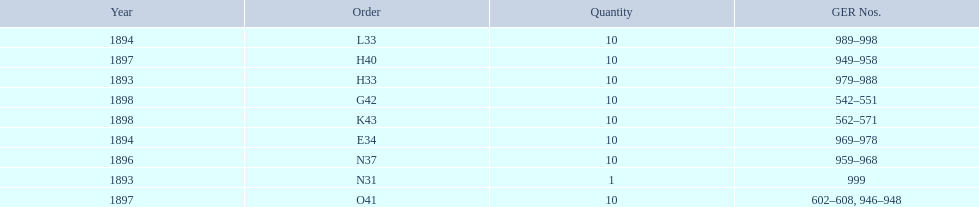What is the total number of locomotives made during this time? 81. 